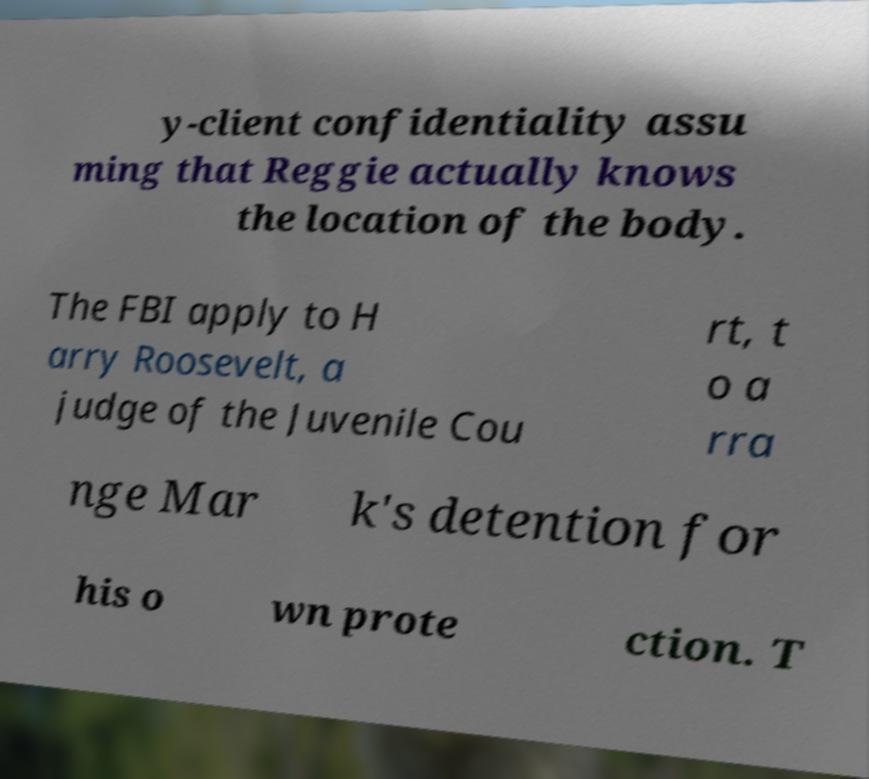Please read and relay the text visible in this image. What does it say? y-client confidentiality assu ming that Reggie actually knows the location of the body. The FBI apply to H arry Roosevelt, a judge of the Juvenile Cou rt, t o a rra nge Mar k's detention for his o wn prote ction. T 